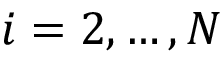Convert formula to latex. <formula><loc_0><loc_0><loc_500><loc_500>i = 2 , \dots , N</formula> 